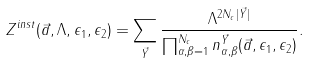Convert formula to latex. <formula><loc_0><loc_0><loc_500><loc_500>Z ^ { i n s t } ( \vec { a } , \Lambda , \epsilon _ { 1 } , \epsilon _ { 2 } ) = \sum _ { \vec { Y } } \frac { \Lambda ^ { 2 N _ { c } | \vec { Y } | } } { \prod _ { \alpha , \beta = 1 } ^ { N _ { c } } n _ { \alpha , \beta } ^ { \vec { Y } } ( \vec { a } , \epsilon _ { 1 } , \epsilon _ { 2 } ) } .</formula> 